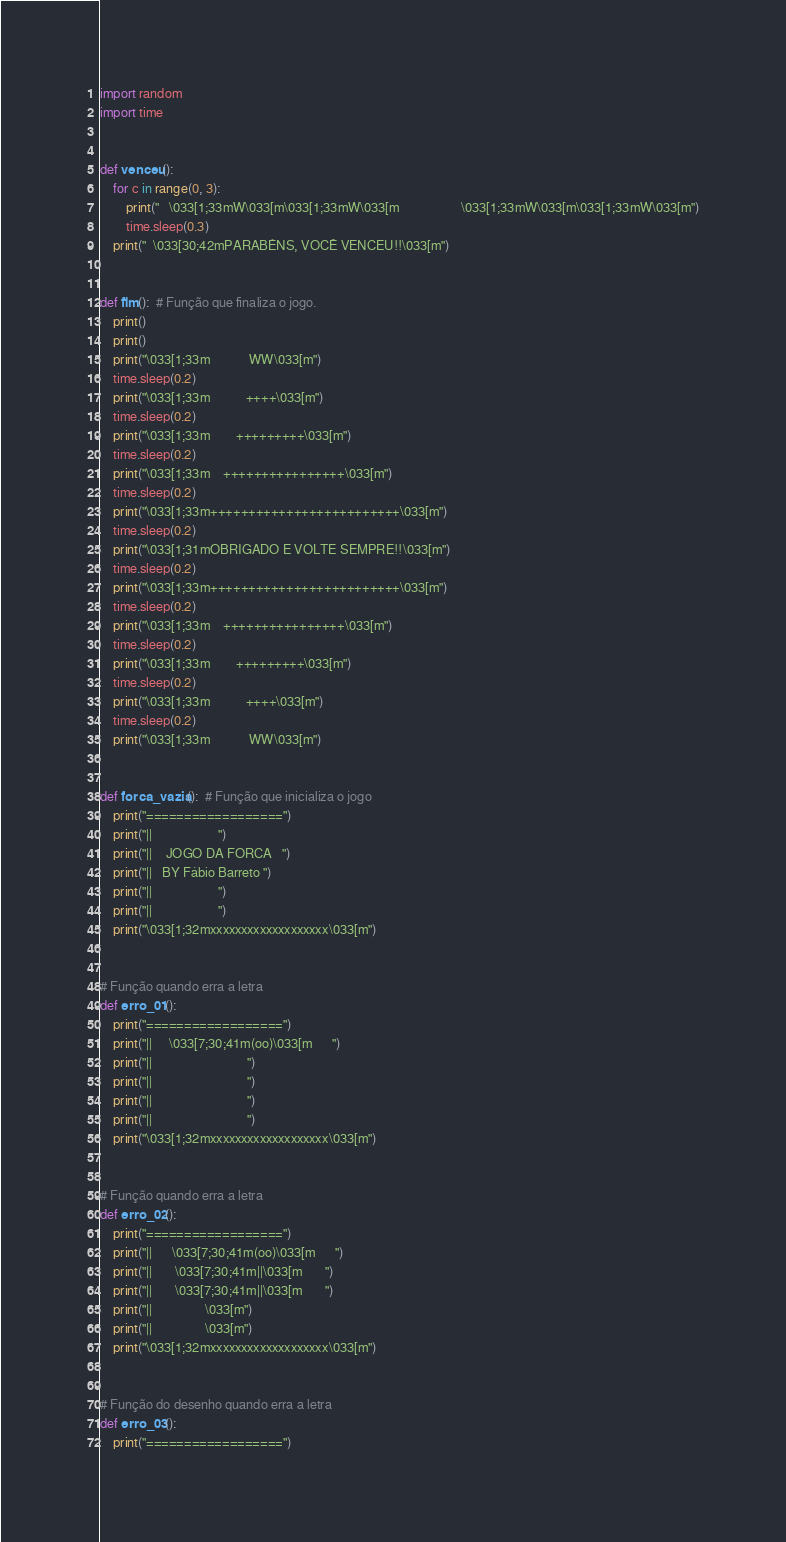Convert code to text. <code><loc_0><loc_0><loc_500><loc_500><_Python_>import random
import time


def venceu():
    for c in range(0, 3):
        print("   \033[1;33mW\033[m\033[1;33mW\033[m                   \033[1;33mW\033[m\033[1;33mW\033[m")
        time.sleep(0.3)
    print("  \033[30;42mPARABÉNS, VOCÊ VENCEU!!\033[m")


def fim():  # Função que finaliza o jogo.
    print()
    print()
    print("\033[1;33m            WW\033[m")
    time.sleep(0.2)
    print("\033[1;33m           ++++\033[m")
    time.sleep(0.2)
    print("\033[1;33m        +++++++++\033[m")
    time.sleep(0.2)
    print("\033[1;33m    ++++++++++++++++\033[m")
    time.sleep(0.2)
    print("\033[1;33m+++++++++++++++++++++++++\033[m")
    time.sleep(0.2)
    print("\033[1;31mOBRIGADO E VOLTE SEMPRE!!\033[m")
    time.sleep(0.2)
    print("\033[1;33m+++++++++++++++++++++++++\033[m")
    time.sleep(0.2)
    print("\033[1;33m    ++++++++++++++++\033[m")
    time.sleep(0.2)
    print("\033[1;33m        +++++++++\033[m")
    time.sleep(0.2)
    print("\033[1;33m           ++++\033[m")
    time.sleep(0.2)
    print("\033[1;33m            WW\033[m")


def forca_vazia():  # Função que inicializa o jogo
    print("==================")
    print("||                    ")
    print("||    JOGO DA FORCA   ")
    print("||   BY Fábio Barreto ")
    print("||                    ")
    print("||                    ")
    print("\033[1;32mxxxxxxxxxxxxxxxxxxx\033[m")


# Função quando erra a letra
def erro_01():
    print("==================")
    print("||     \033[7;30;41m(oo)\033[m      ")
    print("||                             ")
    print("||                             ")
    print("||                             ")
    print("||                             ")
    print("\033[1;32mxxxxxxxxxxxxxxxxxxx\033[m")


# Função quando erra a letra
def erro_02():
    print("==================")
    print("||      \033[7;30;41m(oo)\033[m      ")
    print("||       \033[7;30;41m||\033[m       ")
    print("||       \033[7;30;41m||\033[m       ")
    print("||                \033[m")
    print("||                \033[m")
    print("\033[1;32mxxxxxxxxxxxxxxxxxxx\033[m")


# Função do desenho quando erra a letra
def erro_03():
    print("==================")</code> 